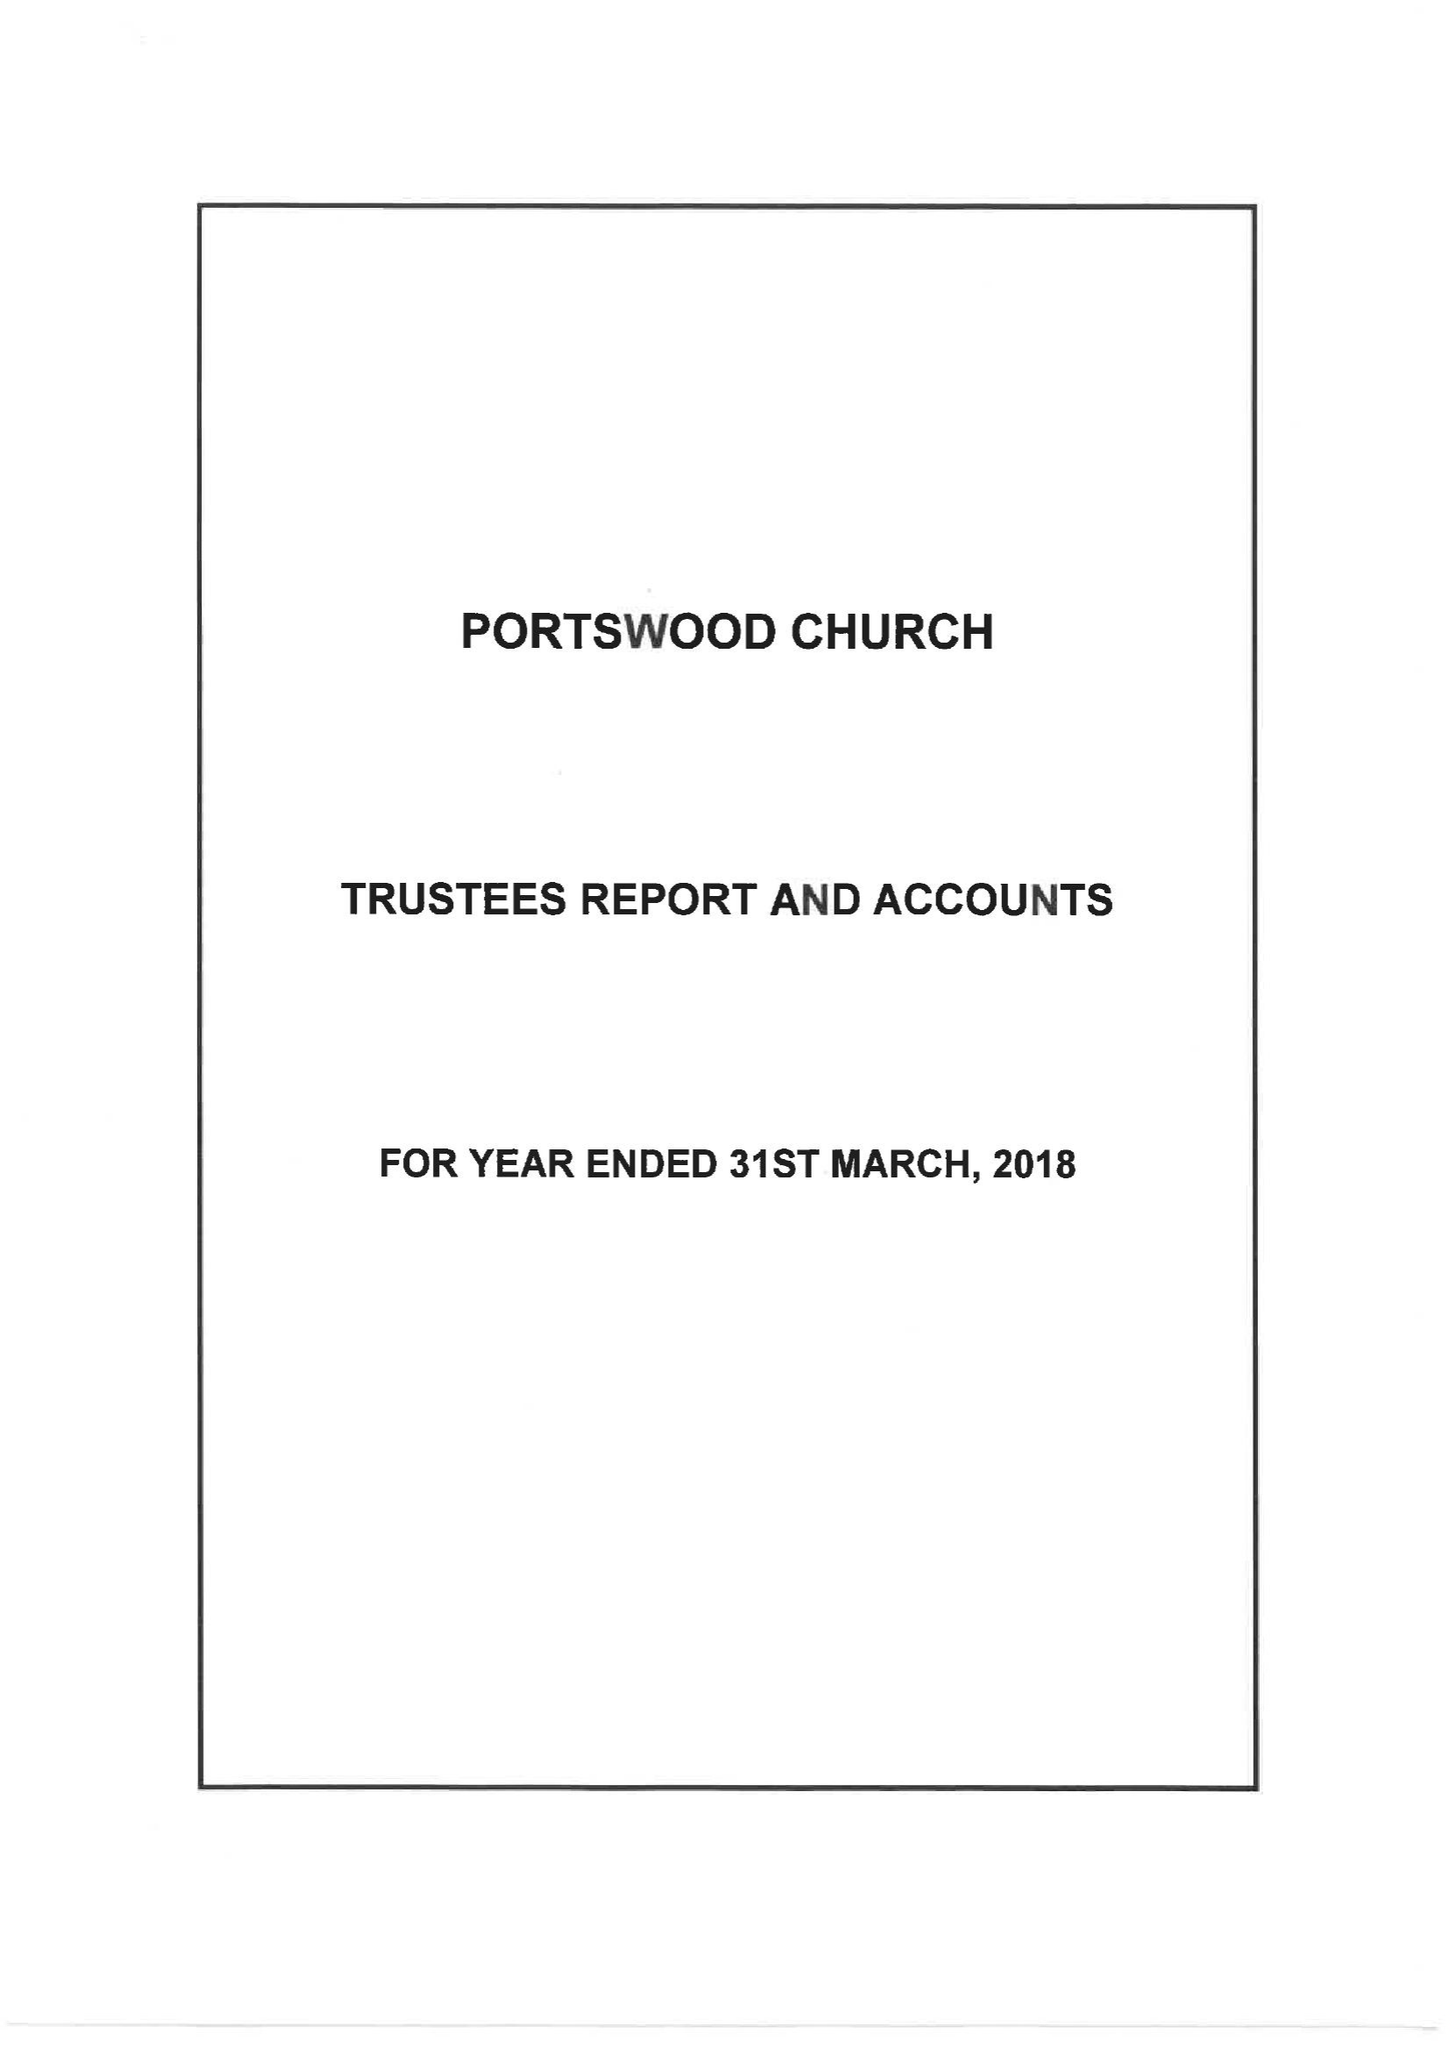What is the value for the spending_annually_in_british_pounds?
Answer the question using a single word or phrase. 299025.00 